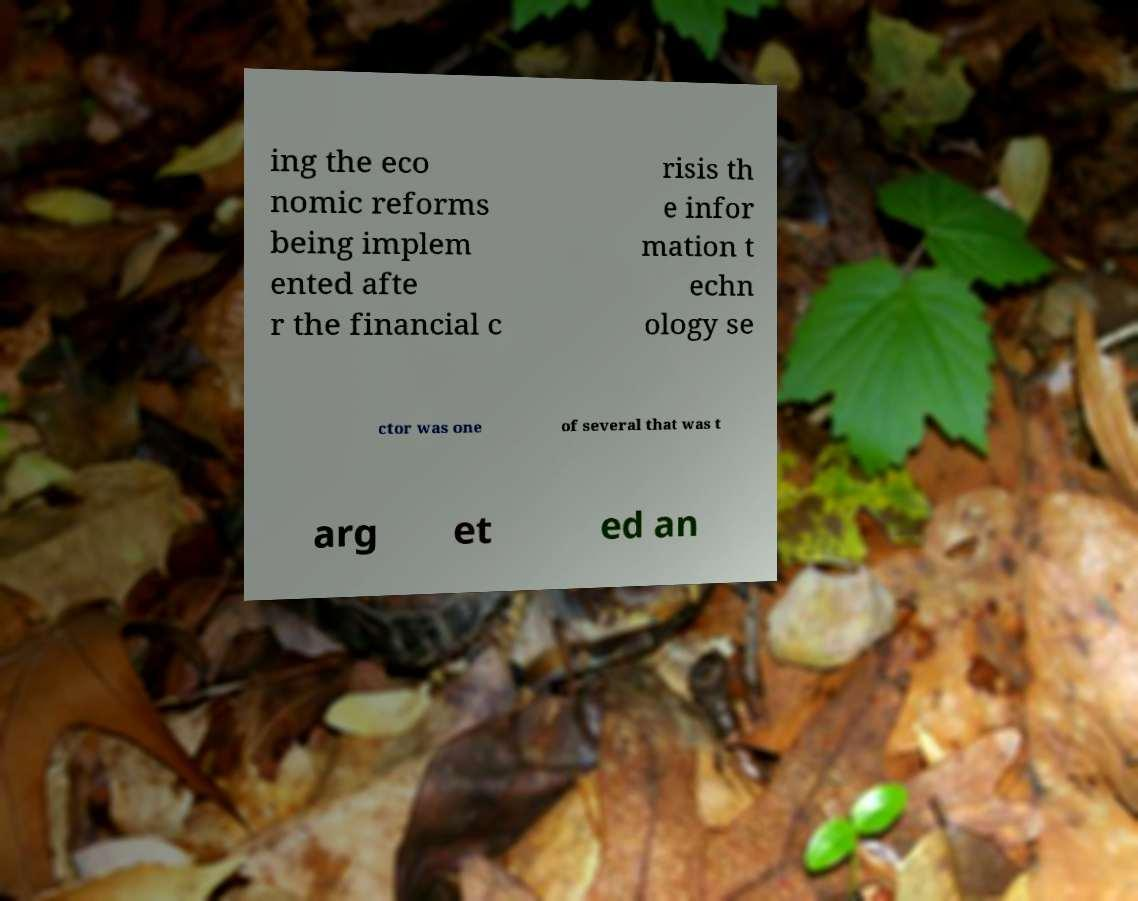Can you read and provide the text displayed in the image?This photo seems to have some interesting text. Can you extract and type it out for me? ing the eco nomic reforms being implem ented afte r the financial c risis th e infor mation t echn ology se ctor was one of several that was t arg et ed an 